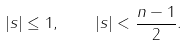<formula> <loc_0><loc_0><loc_500><loc_500>| s | \leq 1 , \quad | s | < \frac { n - 1 } 2 .</formula> 